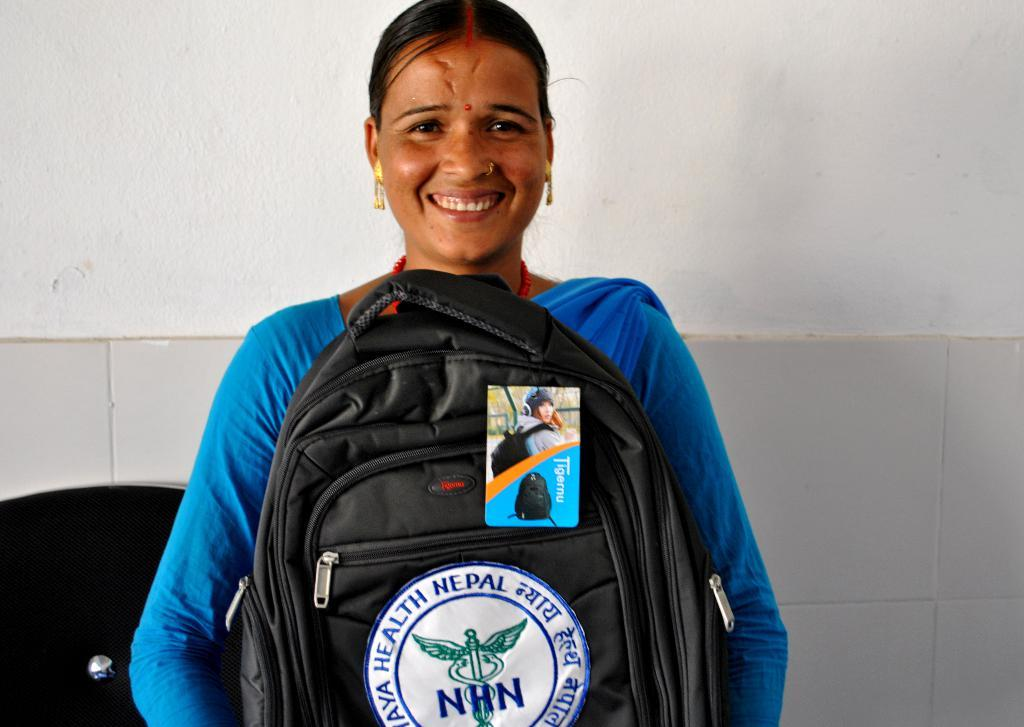<image>
Summarize the visual content of the image. A woman holding a black backpack that has the initials NHN 